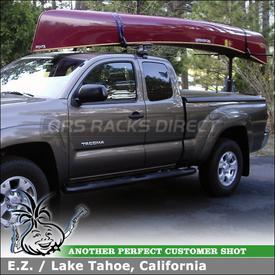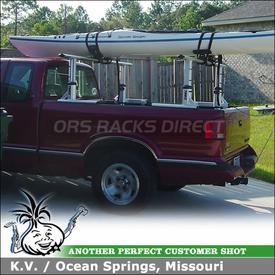The first image is the image on the left, the second image is the image on the right. Examine the images to the left and right. Is the description "A body of water is visible behind a truck" accurate? Answer yes or no. No. 